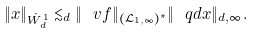<formula> <loc_0><loc_0><loc_500><loc_500>\| x \| _ { \dot { W } _ { d } ^ { 1 } } \lesssim _ { d } \| \ v f \| _ { ( { \mathcal { L } } _ { 1 , \infty } ) ^ { * } } \| \ q d x \| _ { d , \infty } .</formula> 